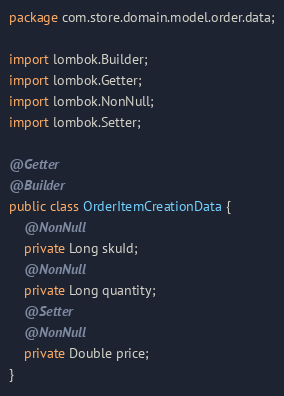Convert code to text. <code><loc_0><loc_0><loc_500><loc_500><_Java_>package com.store.domain.model.order.data;

import lombok.Builder;
import lombok.Getter;
import lombok.NonNull;
import lombok.Setter;

@Getter
@Builder
public class OrderItemCreationData {
	@NonNull
	private Long skuId;
	@NonNull
	private Long quantity;
	@Setter
	@NonNull
	private Double price;
}
</code> 